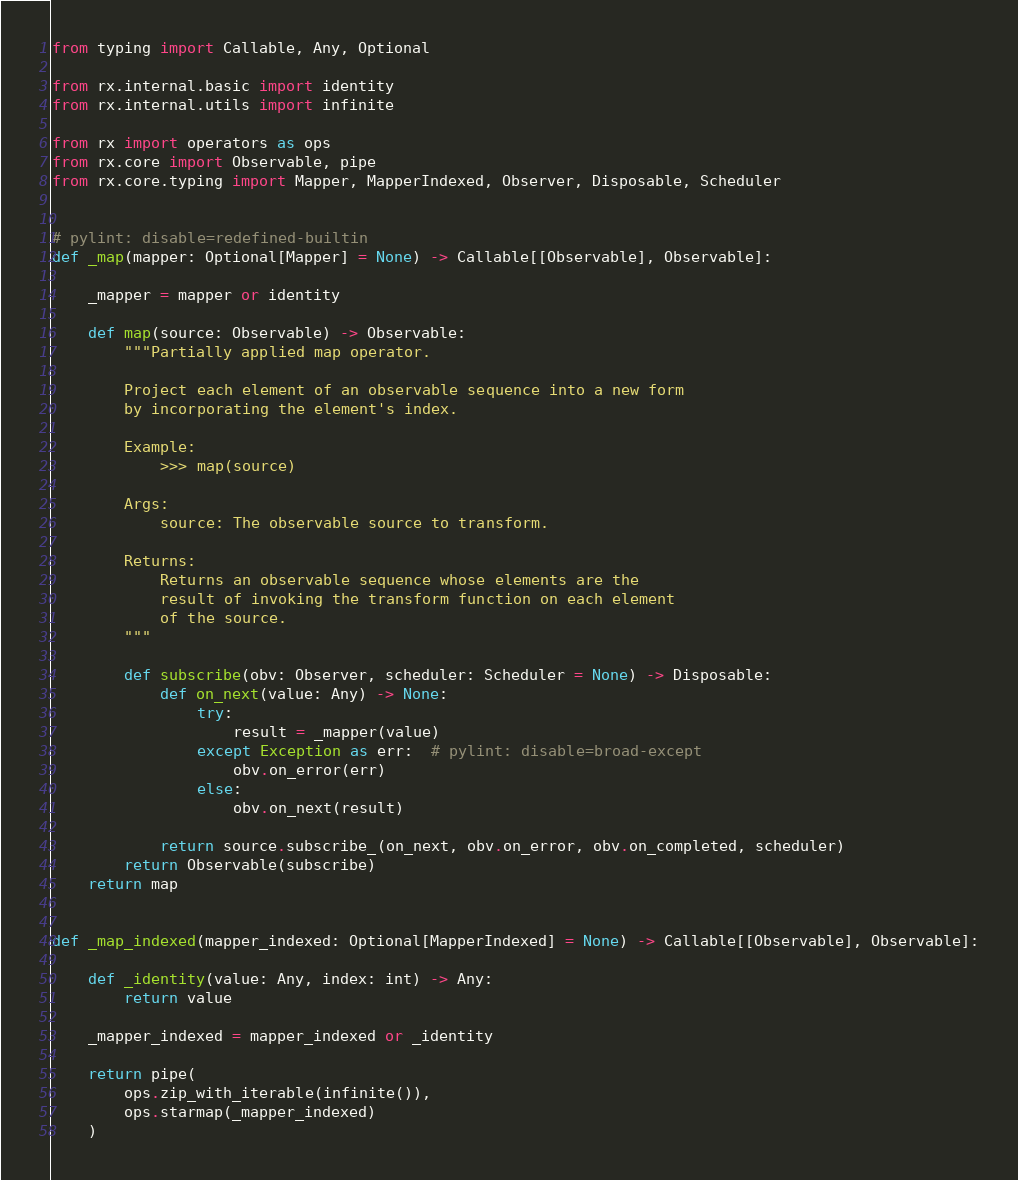<code> <loc_0><loc_0><loc_500><loc_500><_Python_>from typing import Callable, Any, Optional

from rx.internal.basic import identity
from rx.internal.utils import infinite

from rx import operators as ops
from rx.core import Observable, pipe
from rx.core.typing import Mapper, MapperIndexed, Observer, Disposable, Scheduler


# pylint: disable=redefined-builtin
def _map(mapper: Optional[Mapper] = None) -> Callable[[Observable], Observable]:

    _mapper = mapper or identity

    def map(source: Observable) -> Observable:
        """Partially applied map operator.

        Project each element of an observable sequence into a new form
        by incorporating the element's index.

        Example:
            >>> map(source)

        Args:
            source: The observable source to transform.

        Returns:
            Returns an observable sequence whose elements are the
            result of invoking the transform function on each element
            of the source.
        """

        def subscribe(obv: Observer, scheduler: Scheduler = None) -> Disposable:
            def on_next(value: Any) -> None:
                try:
                    result = _mapper(value)
                except Exception as err:  # pylint: disable=broad-except
                    obv.on_error(err)
                else:
                    obv.on_next(result)

            return source.subscribe_(on_next, obv.on_error, obv.on_completed, scheduler)
        return Observable(subscribe)
    return map


def _map_indexed(mapper_indexed: Optional[MapperIndexed] = None) -> Callable[[Observable], Observable]:

    def _identity(value: Any, index: int) -> Any:
        return value

    _mapper_indexed = mapper_indexed or _identity

    return pipe(
        ops.zip_with_iterable(infinite()),
        ops.starmap(_mapper_indexed)
    )
</code> 